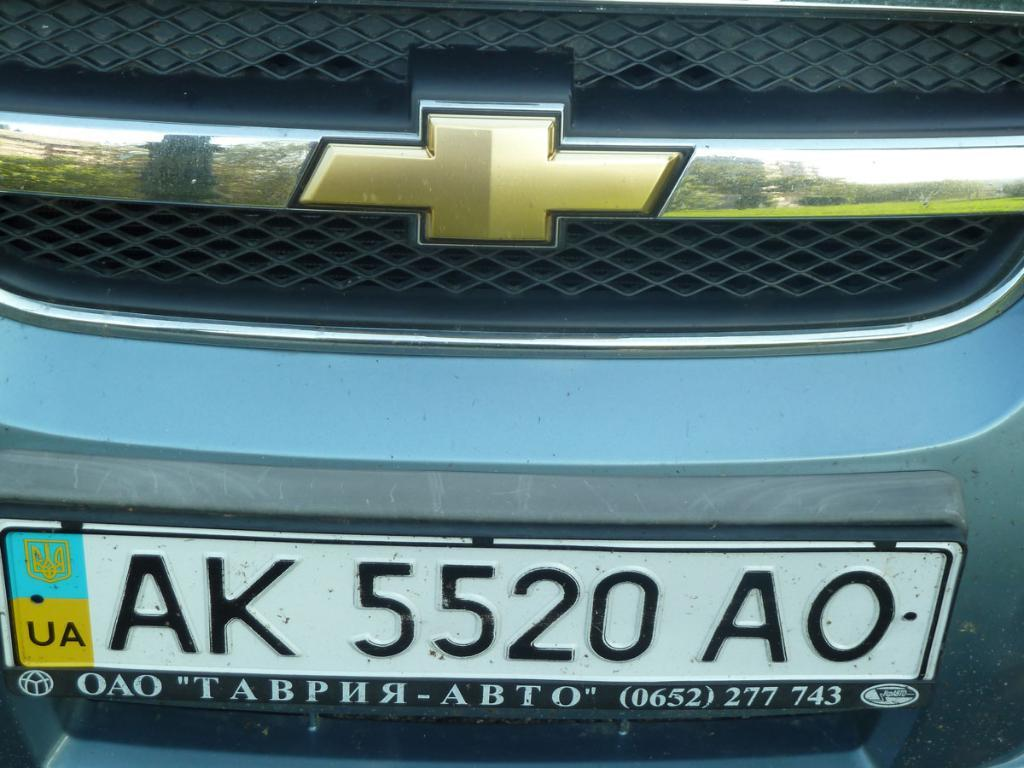<image>
Write a terse but informative summary of the picture. A Chevy has a license plate that reads "AK 5520 AO" 